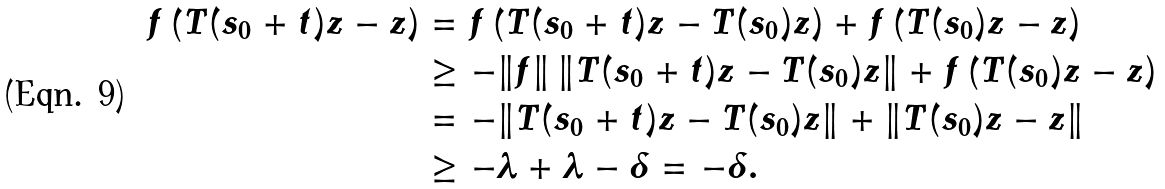Convert formula to latex. <formula><loc_0><loc_0><loc_500><loc_500>f \left ( T ( s _ { 0 } + t ) z - z \right ) & = f \left ( T ( s _ { 0 } + t ) z - T ( s _ { 0 } ) z \right ) + f \left ( T ( s _ { 0 } ) z - z \right ) \\ & \geq - \| f \| \, \| T ( s _ { 0 } + t ) z - T ( s _ { 0 } ) z \| + f \left ( T ( s _ { 0 } ) z - z \right ) \\ & = - \| T ( s _ { 0 } + t ) z - T ( s _ { 0 } ) z \| + \| T ( s _ { 0 } ) z - z \| \\ & \geq - \lambda + \lambda - \delta = - \delta .</formula> 